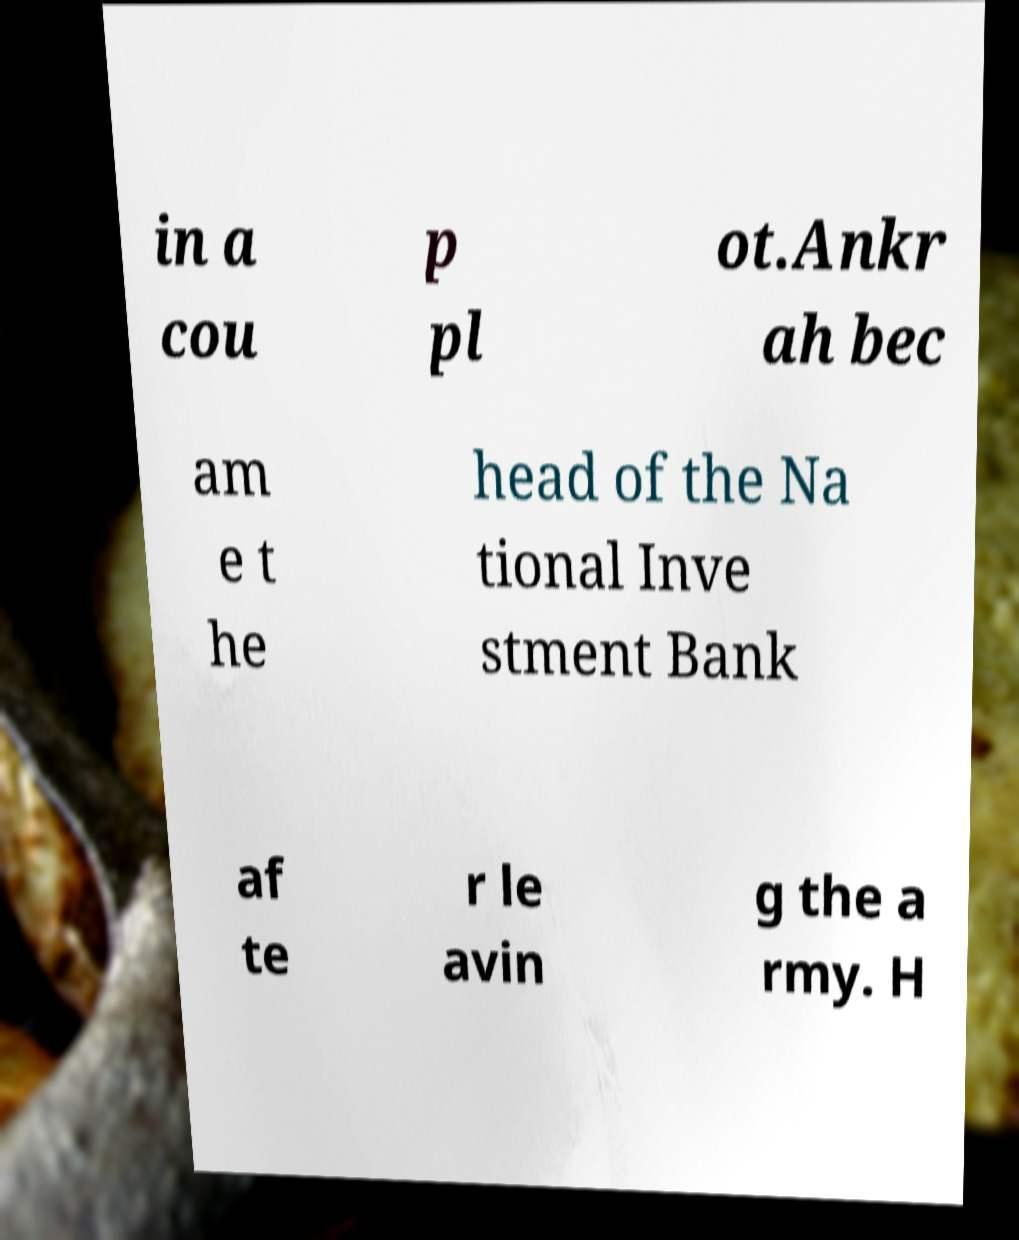For documentation purposes, I need the text within this image transcribed. Could you provide that? in a cou p pl ot.Ankr ah bec am e t he head of the Na tional Inve stment Bank af te r le avin g the a rmy. H 